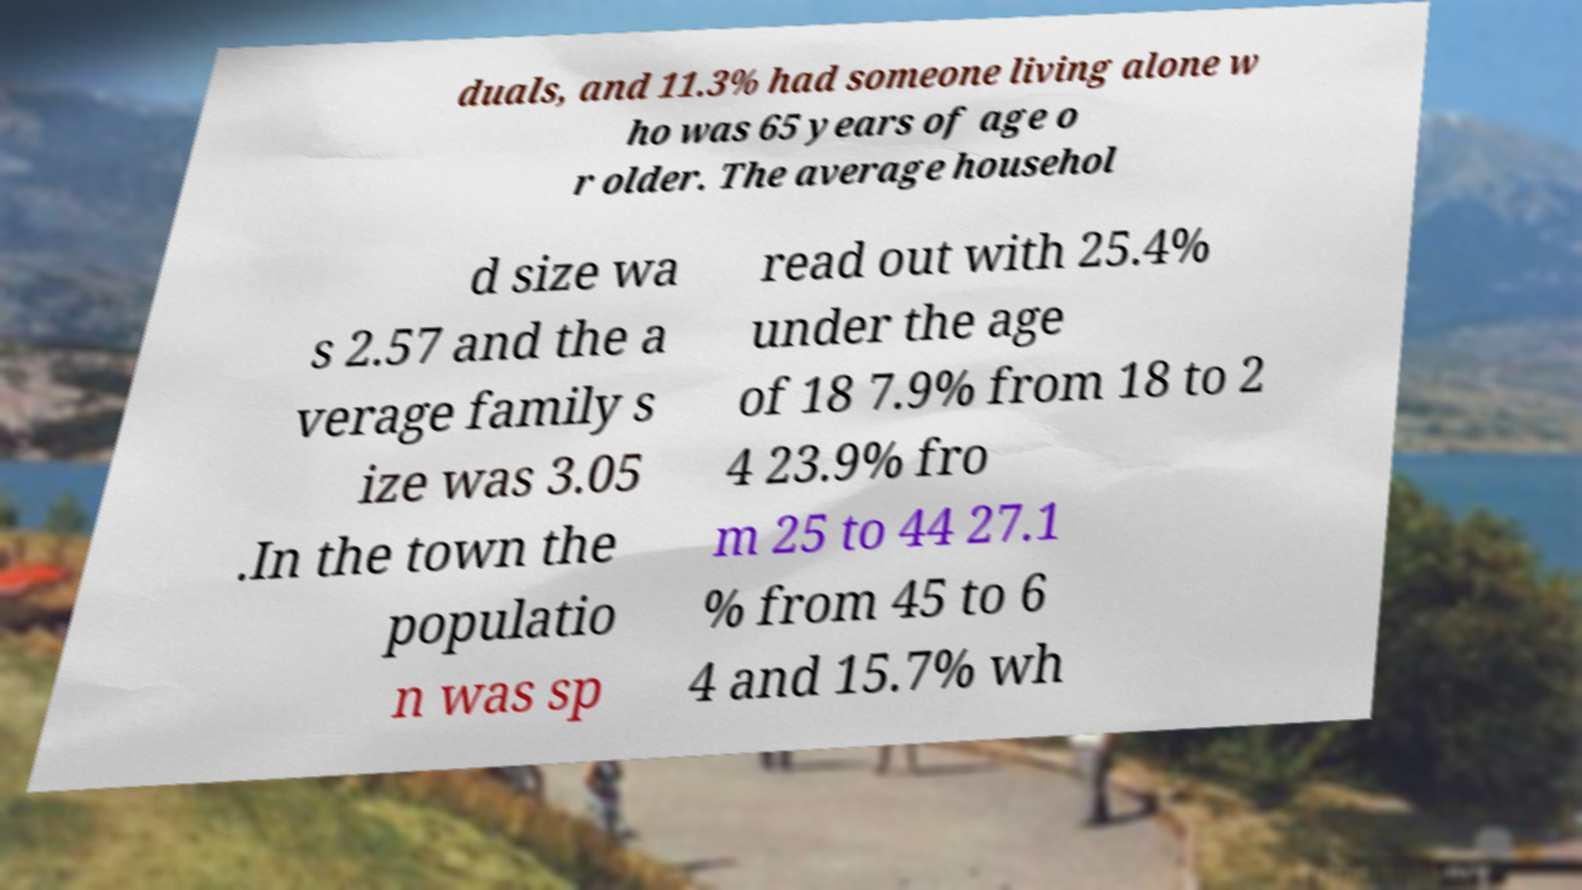What messages or text are displayed in this image? I need them in a readable, typed format. duals, and 11.3% had someone living alone w ho was 65 years of age o r older. The average househol d size wa s 2.57 and the a verage family s ize was 3.05 .In the town the populatio n was sp read out with 25.4% under the age of 18 7.9% from 18 to 2 4 23.9% fro m 25 to 44 27.1 % from 45 to 6 4 and 15.7% wh 